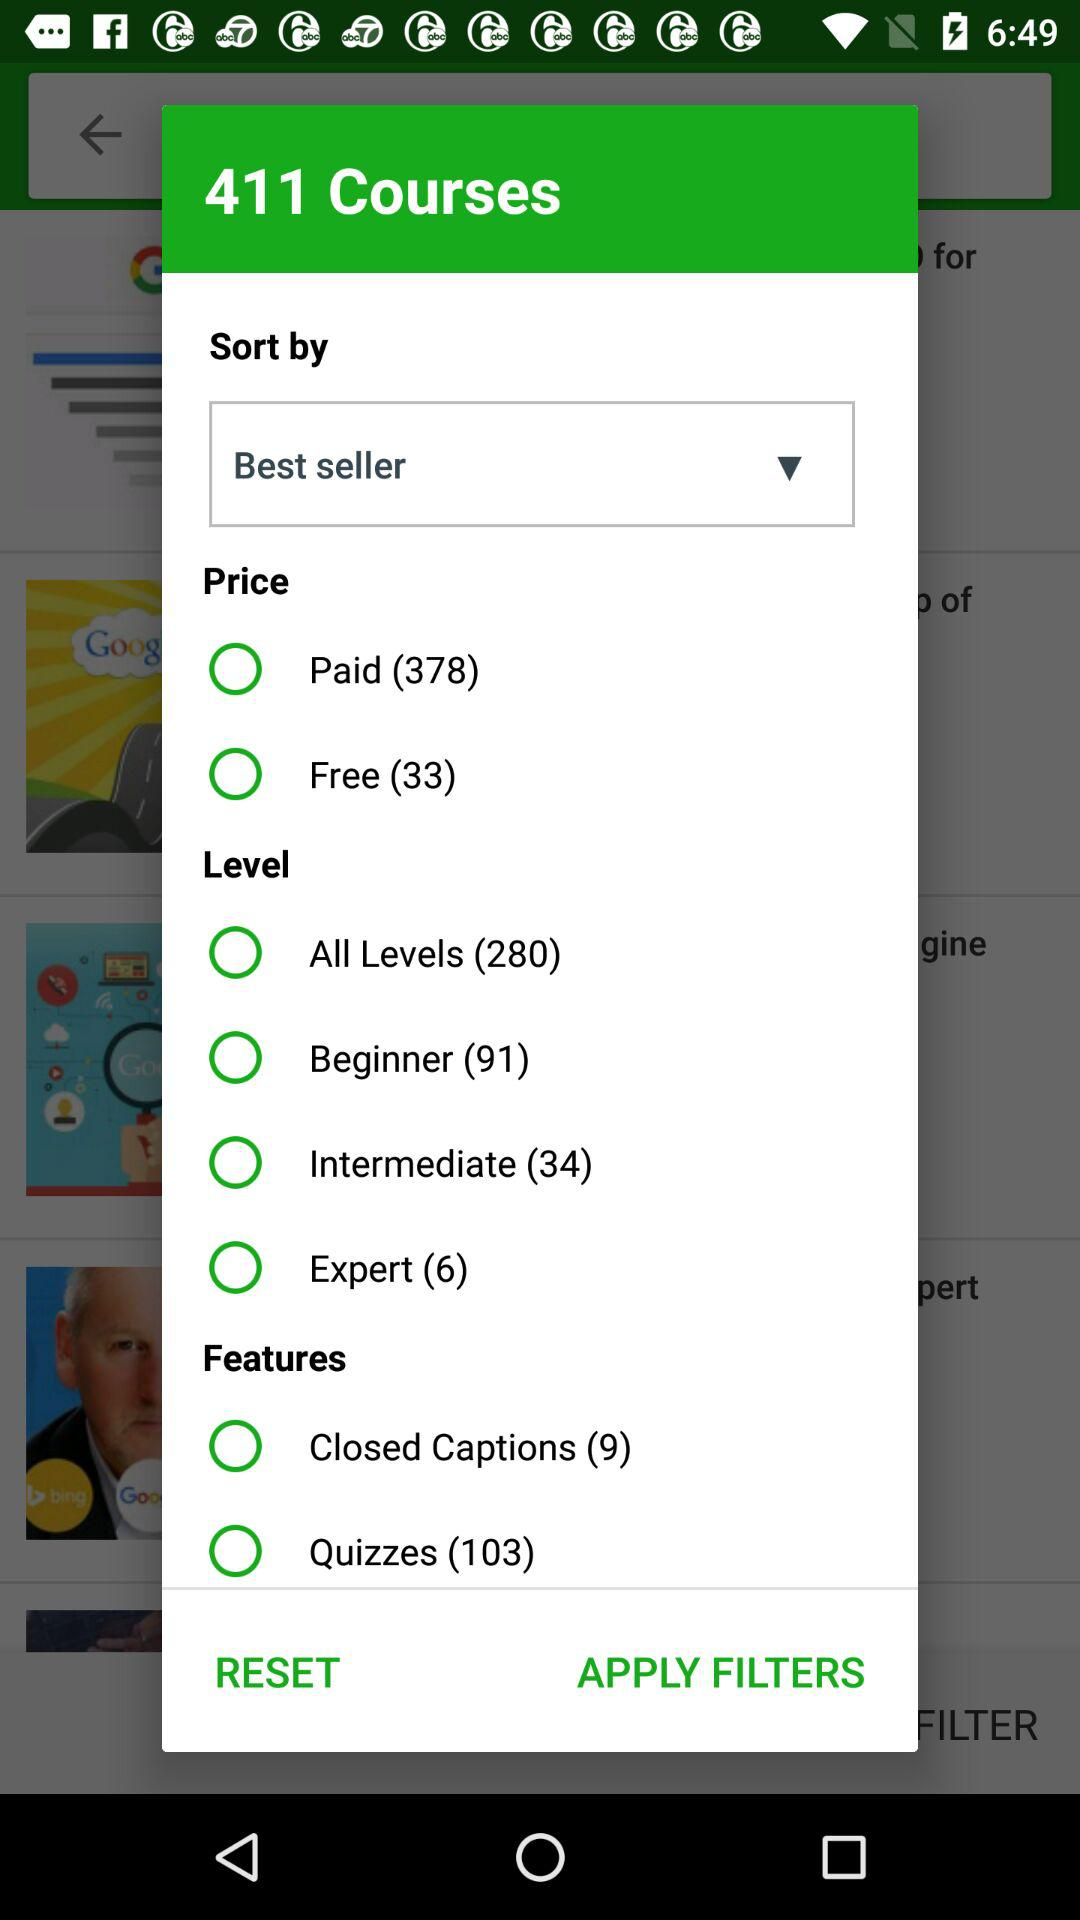How many courses at beginner level are provided? There are 91 courses. 